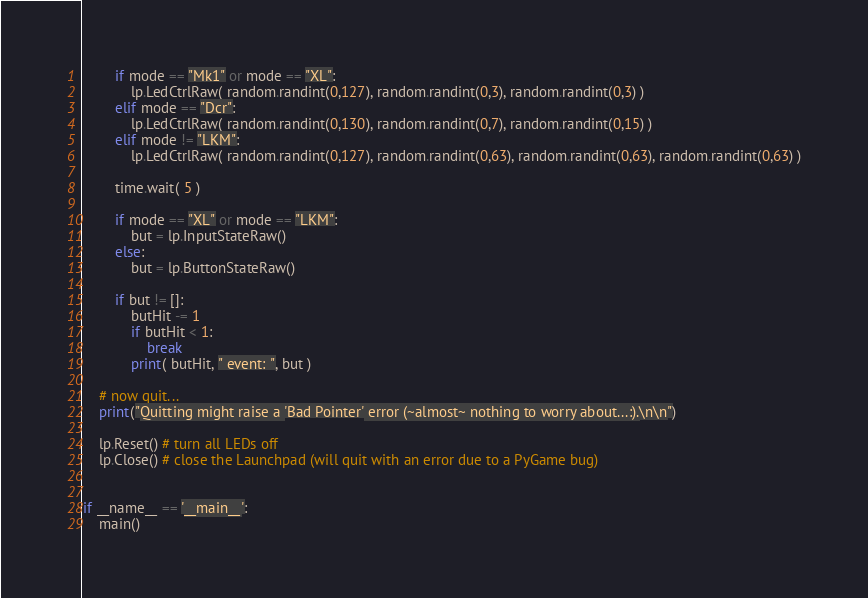<code> <loc_0><loc_0><loc_500><loc_500><_Python_>		if mode == "Mk1" or mode == "XL":
			lp.LedCtrlRaw( random.randint(0,127), random.randint(0,3), random.randint(0,3) )
		elif mode == "Dcr":
			lp.LedCtrlRaw( random.randint(0,130), random.randint(0,7), random.randint(0,15) )
		elif mode != "LKM":
			lp.LedCtrlRaw( random.randint(0,127), random.randint(0,63), random.randint(0,63), random.randint(0,63) )
		
		time.wait( 5 )
		
		if mode == "XL" or mode == "LKM":
			but = lp.InputStateRaw()
		else:
			but = lp.ButtonStateRaw()

		if but != []:
			butHit -= 1
			if butHit < 1:
				break
			print( butHit, " event: ", but )

	# now quit...
	print("Quitting might raise a 'Bad Pointer' error (~almost~ nothing to worry about...:).\n\n")

	lp.Reset() # turn all LEDs off
	lp.Close() # close the Launchpad (will quit with an error due to a PyGame bug)

	
if __name__ == '__main__':
	main()

</code> 